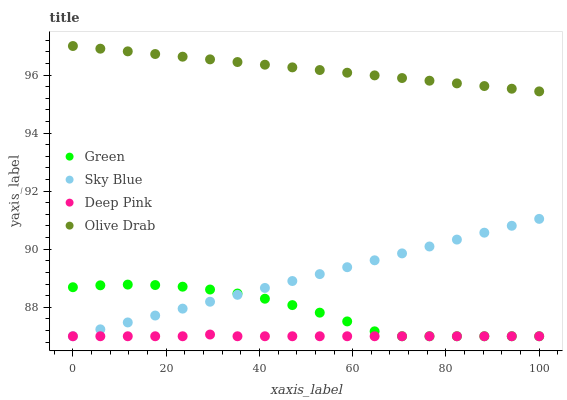Does Deep Pink have the minimum area under the curve?
Answer yes or no. Yes. Does Olive Drab have the maximum area under the curve?
Answer yes or no. Yes. Does Green have the minimum area under the curve?
Answer yes or no. No. Does Green have the maximum area under the curve?
Answer yes or no. No. Is Olive Drab the smoothest?
Answer yes or no. Yes. Is Green the roughest?
Answer yes or no. Yes. Is Deep Pink the smoothest?
Answer yes or no. No. Is Deep Pink the roughest?
Answer yes or no. No. Does Sky Blue have the lowest value?
Answer yes or no. Yes. Does Olive Drab have the lowest value?
Answer yes or no. No. Does Olive Drab have the highest value?
Answer yes or no. Yes. Does Green have the highest value?
Answer yes or no. No. Is Green less than Olive Drab?
Answer yes or no. Yes. Is Olive Drab greater than Green?
Answer yes or no. Yes. Does Green intersect Deep Pink?
Answer yes or no. Yes. Is Green less than Deep Pink?
Answer yes or no. No. Is Green greater than Deep Pink?
Answer yes or no. No. Does Green intersect Olive Drab?
Answer yes or no. No. 